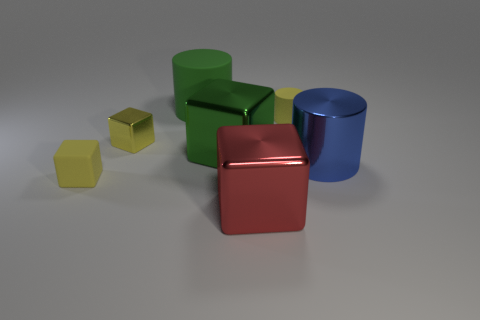Can you describe the colors and materials of the objects in the image? Certainly! The image displays objects with reflective surfaces indicating they are metallic. Specifically, we see a red and a green cube with shiny finishes, a blue cylinder with a similar reflective quality, and two smaller matte cubes, one yellow and another that appears to be a shade of yellowish-green or olive. 